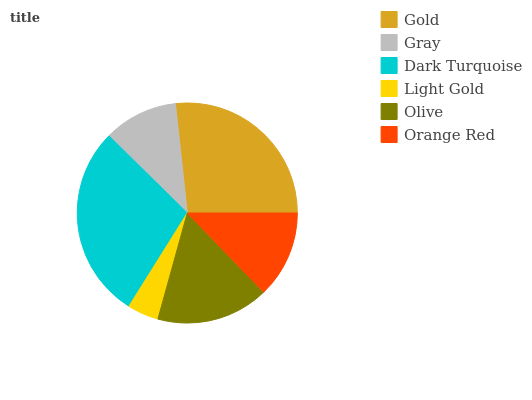Is Light Gold the minimum?
Answer yes or no. Yes. Is Dark Turquoise the maximum?
Answer yes or no. Yes. Is Gray the minimum?
Answer yes or no. No. Is Gray the maximum?
Answer yes or no. No. Is Gold greater than Gray?
Answer yes or no. Yes. Is Gray less than Gold?
Answer yes or no. Yes. Is Gray greater than Gold?
Answer yes or no. No. Is Gold less than Gray?
Answer yes or no. No. Is Olive the high median?
Answer yes or no. Yes. Is Orange Red the low median?
Answer yes or no. Yes. Is Light Gold the high median?
Answer yes or no. No. Is Light Gold the low median?
Answer yes or no. No. 